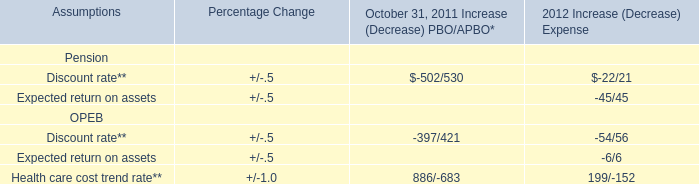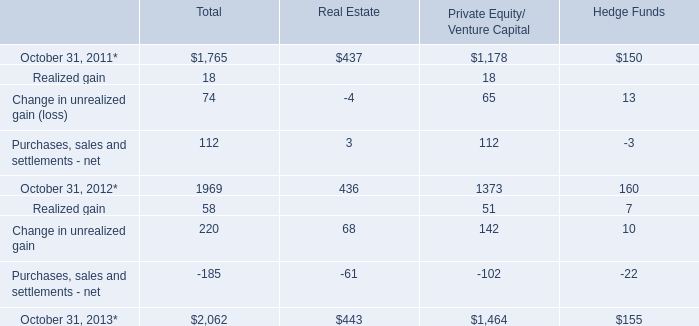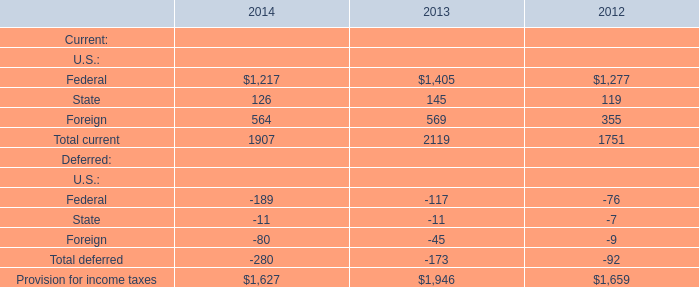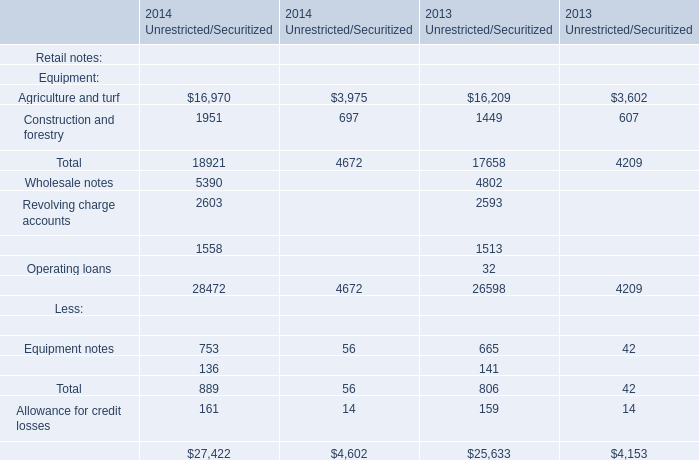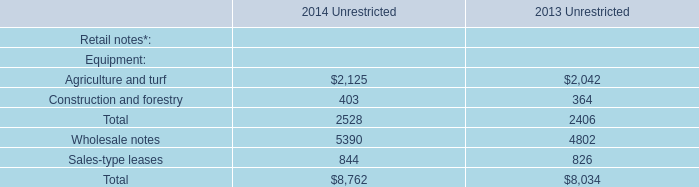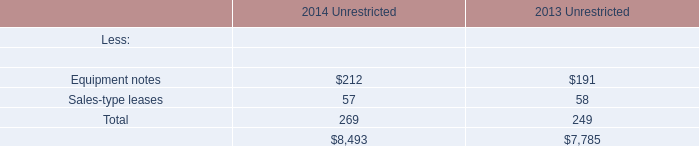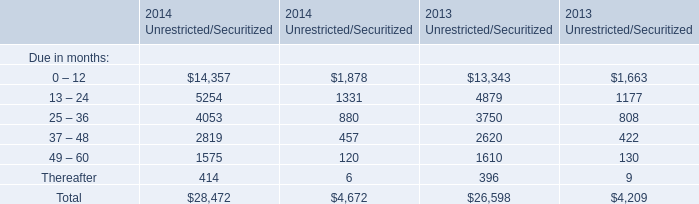What's the current growth rate of Due in months(0-12) in Unrestricted? 
Computations: ((14357 - 13343) / 13343)
Answer: 0.07599. 